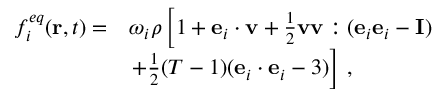Convert formula to latex. <formula><loc_0><loc_0><loc_500><loc_500>\begin{array} { r l } { f _ { i } ^ { e q } ( r , t ) = } & { \omega _ { i } \rho \left [ 1 + e _ { i } \cdot v + \frac { 1 } { 2 } v v \colon ( e _ { i } e _ { i } - I ) } \\ & { + \frac { 1 } { 2 } ( T - 1 ) ( e _ { i } \cdot e _ { i } - 3 ) \right ] \, , } \end{array}</formula> 